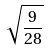Convert formula to latex. <formula><loc_0><loc_0><loc_500><loc_500>\sqrt { \frac { 9 } { 2 8 } }</formula> 